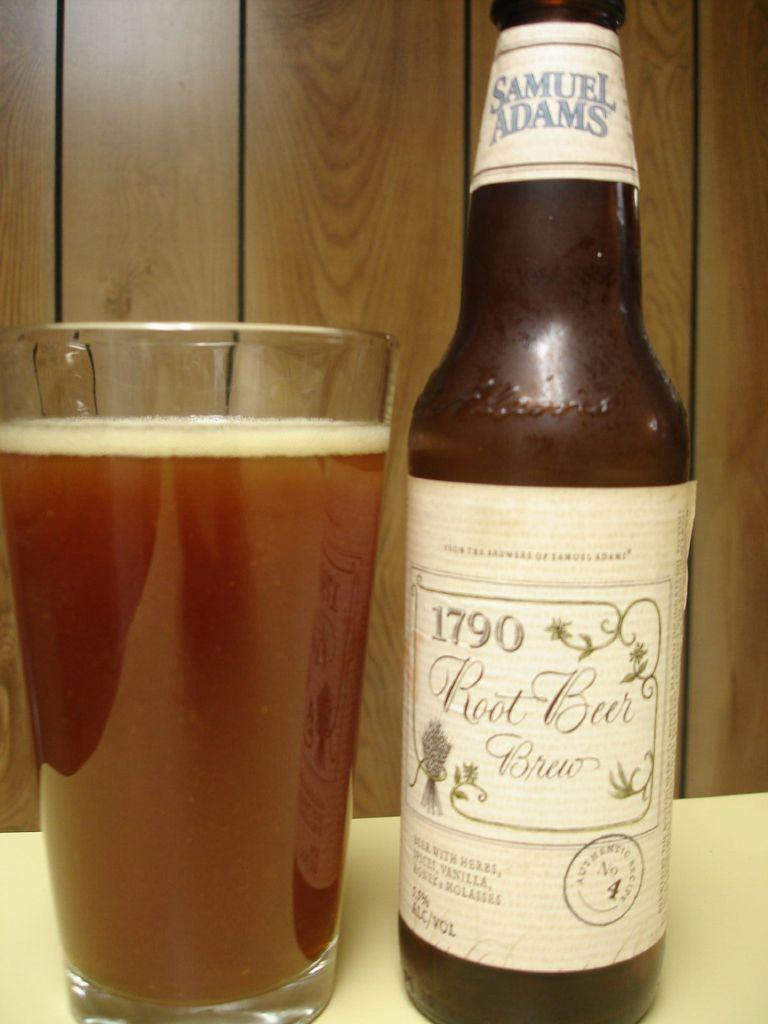Provide a one-sentence caption for the provided image. A Samuel Adams beer bottle next to a glass filled with the beer. 